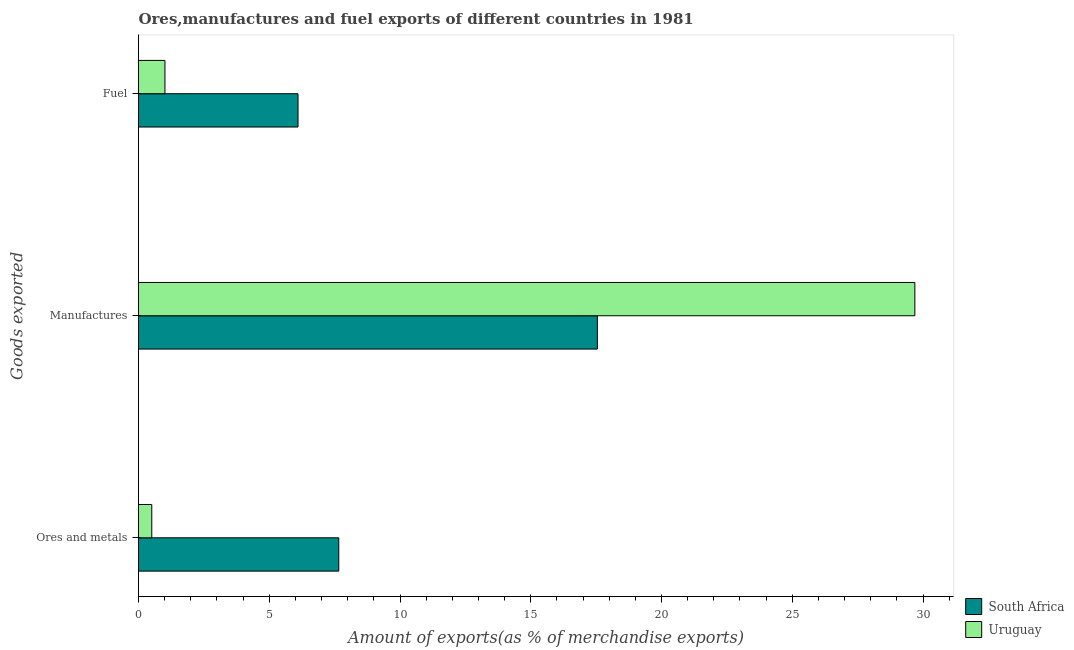How many different coloured bars are there?
Your answer should be compact. 2. Are the number of bars per tick equal to the number of legend labels?
Your response must be concise. Yes. Are the number of bars on each tick of the Y-axis equal?
Ensure brevity in your answer.  Yes. How many bars are there on the 3rd tick from the bottom?
Your answer should be compact. 2. What is the label of the 1st group of bars from the top?
Give a very brief answer. Fuel. What is the percentage of ores and metals exports in Uruguay?
Keep it short and to the point. 0.51. Across all countries, what is the maximum percentage of fuel exports?
Your response must be concise. 6.1. Across all countries, what is the minimum percentage of manufactures exports?
Keep it short and to the point. 17.55. In which country was the percentage of manufactures exports maximum?
Give a very brief answer. Uruguay. In which country was the percentage of fuel exports minimum?
Provide a short and direct response. Uruguay. What is the total percentage of manufactures exports in the graph?
Your answer should be very brief. 47.23. What is the difference between the percentage of fuel exports in Uruguay and that in South Africa?
Keep it short and to the point. -5.09. What is the difference between the percentage of fuel exports in Uruguay and the percentage of ores and metals exports in South Africa?
Offer a terse response. -6.65. What is the average percentage of manufactures exports per country?
Keep it short and to the point. 23.62. What is the difference between the percentage of fuel exports and percentage of manufactures exports in South Africa?
Keep it short and to the point. -11.45. In how many countries, is the percentage of fuel exports greater than 6 %?
Provide a short and direct response. 1. What is the ratio of the percentage of manufactures exports in South Africa to that in Uruguay?
Provide a short and direct response. 0.59. Is the percentage of ores and metals exports in South Africa less than that in Uruguay?
Offer a terse response. No. What is the difference between the highest and the second highest percentage of fuel exports?
Keep it short and to the point. 5.09. What is the difference between the highest and the lowest percentage of manufactures exports?
Keep it short and to the point. 12.14. Is the sum of the percentage of fuel exports in Uruguay and South Africa greater than the maximum percentage of manufactures exports across all countries?
Give a very brief answer. No. What does the 2nd bar from the top in Manufactures represents?
Give a very brief answer. South Africa. What does the 2nd bar from the bottom in Manufactures represents?
Offer a terse response. Uruguay. How many bars are there?
Your answer should be very brief. 6. How many countries are there in the graph?
Offer a very short reply. 2. Are the values on the major ticks of X-axis written in scientific E-notation?
Make the answer very short. No. Does the graph contain grids?
Your answer should be very brief. No. How many legend labels are there?
Offer a very short reply. 2. How are the legend labels stacked?
Ensure brevity in your answer.  Vertical. What is the title of the graph?
Ensure brevity in your answer.  Ores,manufactures and fuel exports of different countries in 1981. Does "Venezuela" appear as one of the legend labels in the graph?
Offer a very short reply. No. What is the label or title of the X-axis?
Ensure brevity in your answer.  Amount of exports(as % of merchandise exports). What is the label or title of the Y-axis?
Your response must be concise. Goods exported. What is the Amount of exports(as % of merchandise exports) in South Africa in Ores and metals?
Ensure brevity in your answer.  7.66. What is the Amount of exports(as % of merchandise exports) in Uruguay in Ores and metals?
Give a very brief answer. 0.51. What is the Amount of exports(as % of merchandise exports) in South Africa in Manufactures?
Give a very brief answer. 17.55. What is the Amount of exports(as % of merchandise exports) of Uruguay in Manufactures?
Keep it short and to the point. 29.69. What is the Amount of exports(as % of merchandise exports) of South Africa in Fuel?
Your answer should be compact. 6.1. What is the Amount of exports(as % of merchandise exports) of Uruguay in Fuel?
Give a very brief answer. 1.01. Across all Goods exported, what is the maximum Amount of exports(as % of merchandise exports) of South Africa?
Provide a short and direct response. 17.55. Across all Goods exported, what is the maximum Amount of exports(as % of merchandise exports) of Uruguay?
Keep it short and to the point. 29.69. Across all Goods exported, what is the minimum Amount of exports(as % of merchandise exports) in South Africa?
Offer a terse response. 6.1. Across all Goods exported, what is the minimum Amount of exports(as % of merchandise exports) in Uruguay?
Give a very brief answer. 0.51. What is the total Amount of exports(as % of merchandise exports) in South Africa in the graph?
Offer a very short reply. 31.3. What is the total Amount of exports(as % of merchandise exports) in Uruguay in the graph?
Offer a terse response. 31.21. What is the difference between the Amount of exports(as % of merchandise exports) of South Africa in Ores and metals and that in Manufactures?
Ensure brevity in your answer.  -9.89. What is the difference between the Amount of exports(as % of merchandise exports) of Uruguay in Ores and metals and that in Manufactures?
Provide a short and direct response. -29.18. What is the difference between the Amount of exports(as % of merchandise exports) of South Africa in Ores and metals and that in Fuel?
Provide a short and direct response. 1.56. What is the difference between the Amount of exports(as % of merchandise exports) of Uruguay in Ores and metals and that in Fuel?
Ensure brevity in your answer.  -0.5. What is the difference between the Amount of exports(as % of merchandise exports) of South Africa in Manufactures and that in Fuel?
Offer a terse response. 11.45. What is the difference between the Amount of exports(as % of merchandise exports) of Uruguay in Manufactures and that in Fuel?
Provide a succinct answer. 28.68. What is the difference between the Amount of exports(as % of merchandise exports) in South Africa in Ores and metals and the Amount of exports(as % of merchandise exports) in Uruguay in Manufactures?
Your answer should be very brief. -22.03. What is the difference between the Amount of exports(as % of merchandise exports) in South Africa in Ores and metals and the Amount of exports(as % of merchandise exports) in Uruguay in Fuel?
Keep it short and to the point. 6.65. What is the difference between the Amount of exports(as % of merchandise exports) of South Africa in Manufactures and the Amount of exports(as % of merchandise exports) of Uruguay in Fuel?
Ensure brevity in your answer.  16.53. What is the average Amount of exports(as % of merchandise exports) of South Africa per Goods exported?
Your answer should be very brief. 10.43. What is the average Amount of exports(as % of merchandise exports) in Uruguay per Goods exported?
Provide a succinct answer. 10.4. What is the difference between the Amount of exports(as % of merchandise exports) in South Africa and Amount of exports(as % of merchandise exports) in Uruguay in Ores and metals?
Your answer should be very brief. 7.15. What is the difference between the Amount of exports(as % of merchandise exports) of South Africa and Amount of exports(as % of merchandise exports) of Uruguay in Manufactures?
Offer a very short reply. -12.14. What is the difference between the Amount of exports(as % of merchandise exports) in South Africa and Amount of exports(as % of merchandise exports) in Uruguay in Fuel?
Your answer should be very brief. 5.09. What is the ratio of the Amount of exports(as % of merchandise exports) in South Africa in Ores and metals to that in Manufactures?
Provide a short and direct response. 0.44. What is the ratio of the Amount of exports(as % of merchandise exports) in Uruguay in Ores and metals to that in Manufactures?
Ensure brevity in your answer.  0.02. What is the ratio of the Amount of exports(as % of merchandise exports) of South Africa in Ores and metals to that in Fuel?
Ensure brevity in your answer.  1.26. What is the ratio of the Amount of exports(as % of merchandise exports) of Uruguay in Ores and metals to that in Fuel?
Your answer should be very brief. 0.5. What is the ratio of the Amount of exports(as % of merchandise exports) of South Africa in Manufactures to that in Fuel?
Your answer should be very brief. 2.88. What is the ratio of the Amount of exports(as % of merchandise exports) of Uruguay in Manufactures to that in Fuel?
Your answer should be compact. 29.36. What is the difference between the highest and the second highest Amount of exports(as % of merchandise exports) of South Africa?
Your response must be concise. 9.89. What is the difference between the highest and the second highest Amount of exports(as % of merchandise exports) in Uruguay?
Provide a succinct answer. 28.68. What is the difference between the highest and the lowest Amount of exports(as % of merchandise exports) of South Africa?
Your answer should be compact. 11.45. What is the difference between the highest and the lowest Amount of exports(as % of merchandise exports) of Uruguay?
Make the answer very short. 29.18. 